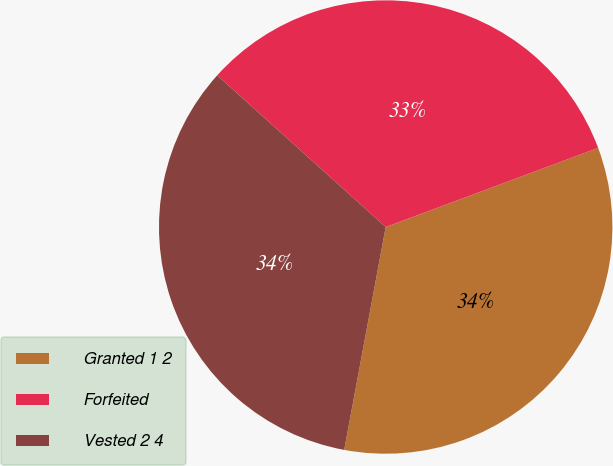Convert chart to OTSL. <chart><loc_0><loc_0><loc_500><loc_500><pie_chart><fcel>Granted 1 2<fcel>Forfeited<fcel>Vested 2 4<nl><fcel>33.61%<fcel>32.66%<fcel>33.74%<nl></chart> 